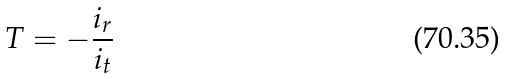Convert formula to latex. <formula><loc_0><loc_0><loc_500><loc_500>T = - \frac { i _ { r } } { i _ { t } }</formula> 